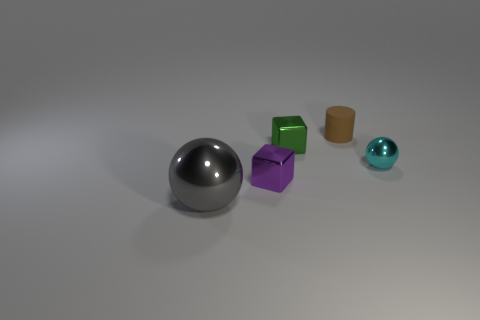Add 1 red rubber blocks. How many objects exist? 6 Subtract all blocks. How many objects are left? 3 Subtract 1 spheres. How many spheres are left? 1 Subtract all cyan balls. How many balls are left? 1 Subtract all cyan cylinders. Subtract all cyan spheres. How many cylinders are left? 1 Subtract all blue cubes. How many gray cylinders are left? 0 Subtract all tiny rubber things. Subtract all cubes. How many objects are left? 2 Add 2 gray metallic spheres. How many gray metallic spheres are left? 3 Add 4 small brown things. How many small brown things exist? 5 Subtract 0 red blocks. How many objects are left? 5 